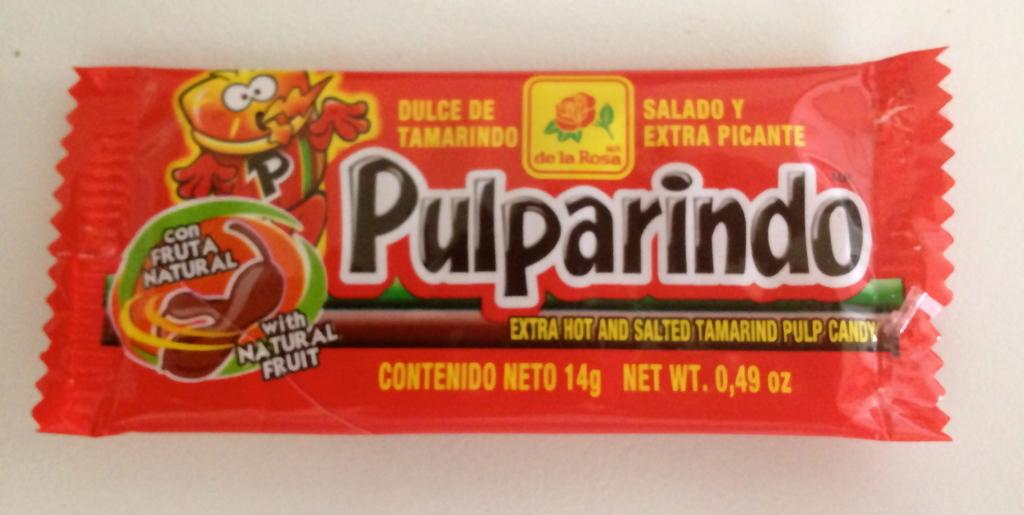<image>
Give a short and clear explanation of the subsequent image. The red package of candy is called Pulparindo. 